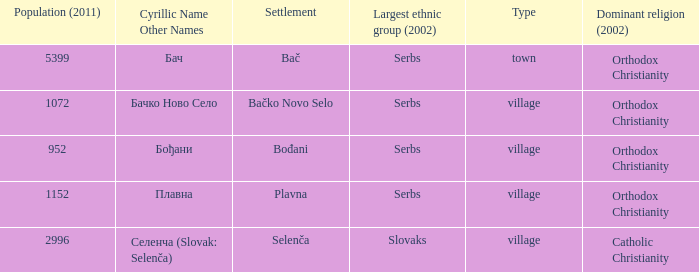What is the smallest population listed? 952.0. 